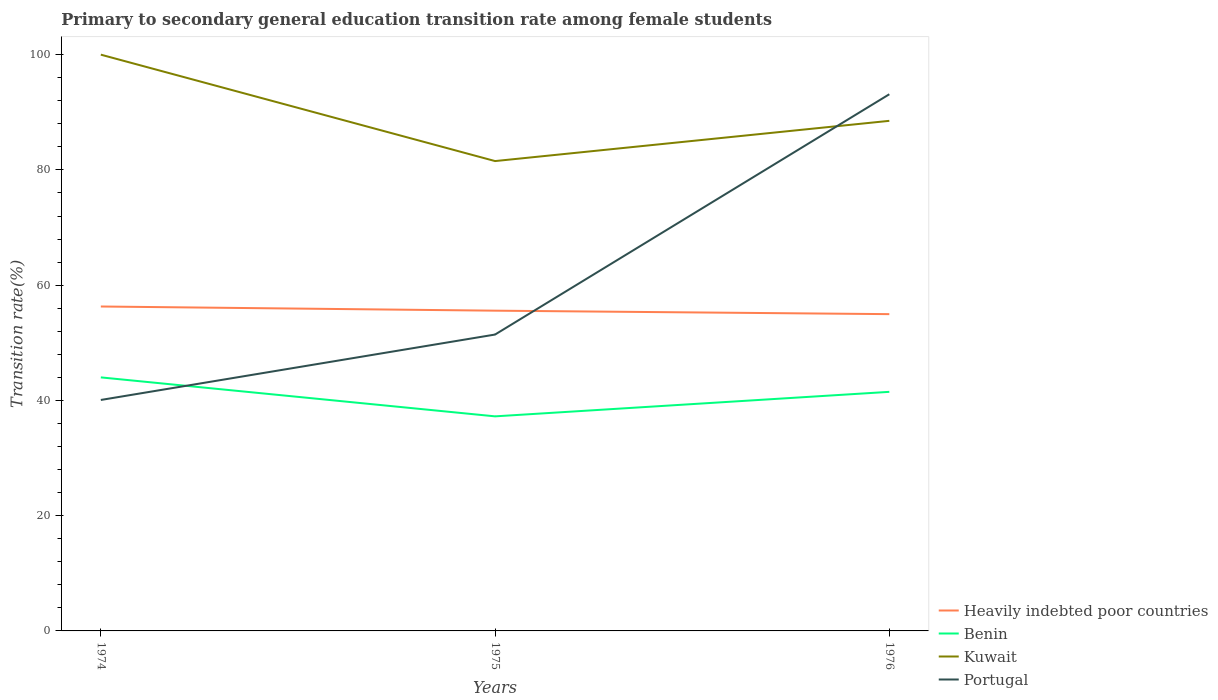Does the line corresponding to Benin intersect with the line corresponding to Kuwait?
Offer a very short reply. No. Across all years, what is the maximum transition rate in Benin?
Give a very brief answer. 37.24. In which year was the transition rate in Heavily indebted poor countries maximum?
Give a very brief answer. 1976. What is the total transition rate in Benin in the graph?
Provide a succinct answer. 6.76. What is the difference between the highest and the second highest transition rate in Portugal?
Ensure brevity in your answer.  53.05. What is the difference between the highest and the lowest transition rate in Heavily indebted poor countries?
Ensure brevity in your answer.  1. How many lines are there?
Provide a succinct answer. 4. How many years are there in the graph?
Your response must be concise. 3. Are the values on the major ticks of Y-axis written in scientific E-notation?
Your answer should be compact. No. Does the graph contain grids?
Keep it short and to the point. No. Where does the legend appear in the graph?
Make the answer very short. Bottom right. How many legend labels are there?
Your answer should be compact. 4. What is the title of the graph?
Your answer should be compact. Primary to secondary general education transition rate among female students. Does "United States" appear as one of the legend labels in the graph?
Your response must be concise. No. What is the label or title of the X-axis?
Give a very brief answer. Years. What is the label or title of the Y-axis?
Provide a short and direct response. Transition rate(%). What is the Transition rate(%) in Heavily indebted poor countries in 1974?
Your answer should be compact. 56.3. What is the Transition rate(%) of Benin in 1974?
Your response must be concise. 44. What is the Transition rate(%) in Portugal in 1974?
Your answer should be very brief. 40.08. What is the Transition rate(%) in Heavily indebted poor countries in 1975?
Offer a terse response. 55.57. What is the Transition rate(%) in Benin in 1975?
Your response must be concise. 37.24. What is the Transition rate(%) of Kuwait in 1975?
Make the answer very short. 81.53. What is the Transition rate(%) in Portugal in 1975?
Provide a succinct answer. 51.43. What is the Transition rate(%) of Heavily indebted poor countries in 1976?
Give a very brief answer. 54.97. What is the Transition rate(%) in Benin in 1976?
Keep it short and to the point. 41.49. What is the Transition rate(%) in Kuwait in 1976?
Keep it short and to the point. 88.52. What is the Transition rate(%) of Portugal in 1976?
Your response must be concise. 93.13. Across all years, what is the maximum Transition rate(%) in Heavily indebted poor countries?
Your answer should be compact. 56.3. Across all years, what is the maximum Transition rate(%) of Benin?
Your answer should be compact. 44. Across all years, what is the maximum Transition rate(%) in Portugal?
Give a very brief answer. 93.13. Across all years, what is the minimum Transition rate(%) in Heavily indebted poor countries?
Offer a terse response. 54.97. Across all years, what is the minimum Transition rate(%) of Benin?
Provide a succinct answer. 37.24. Across all years, what is the minimum Transition rate(%) in Kuwait?
Offer a terse response. 81.53. Across all years, what is the minimum Transition rate(%) of Portugal?
Your answer should be compact. 40.08. What is the total Transition rate(%) of Heavily indebted poor countries in the graph?
Offer a very short reply. 166.84. What is the total Transition rate(%) in Benin in the graph?
Provide a short and direct response. 122.72. What is the total Transition rate(%) of Kuwait in the graph?
Keep it short and to the point. 270.05. What is the total Transition rate(%) in Portugal in the graph?
Give a very brief answer. 184.64. What is the difference between the Transition rate(%) in Heavily indebted poor countries in 1974 and that in 1975?
Your answer should be compact. 0.72. What is the difference between the Transition rate(%) in Benin in 1974 and that in 1975?
Ensure brevity in your answer.  6.76. What is the difference between the Transition rate(%) in Kuwait in 1974 and that in 1975?
Offer a very short reply. 18.47. What is the difference between the Transition rate(%) of Portugal in 1974 and that in 1975?
Provide a succinct answer. -11.35. What is the difference between the Transition rate(%) of Heavily indebted poor countries in 1974 and that in 1976?
Give a very brief answer. 1.32. What is the difference between the Transition rate(%) in Benin in 1974 and that in 1976?
Give a very brief answer. 2.51. What is the difference between the Transition rate(%) of Kuwait in 1974 and that in 1976?
Your answer should be compact. 11.48. What is the difference between the Transition rate(%) of Portugal in 1974 and that in 1976?
Your response must be concise. -53.05. What is the difference between the Transition rate(%) in Heavily indebted poor countries in 1975 and that in 1976?
Provide a succinct answer. 0.6. What is the difference between the Transition rate(%) of Benin in 1975 and that in 1976?
Make the answer very short. -4.25. What is the difference between the Transition rate(%) of Kuwait in 1975 and that in 1976?
Keep it short and to the point. -6.98. What is the difference between the Transition rate(%) of Portugal in 1975 and that in 1976?
Offer a terse response. -41.7. What is the difference between the Transition rate(%) in Heavily indebted poor countries in 1974 and the Transition rate(%) in Benin in 1975?
Your answer should be compact. 19.06. What is the difference between the Transition rate(%) of Heavily indebted poor countries in 1974 and the Transition rate(%) of Kuwait in 1975?
Offer a very short reply. -25.24. What is the difference between the Transition rate(%) of Heavily indebted poor countries in 1974 and the Transition rate(%) of Portugal in 1975?
Offer a very short reply. 4.87. What is the difference between the Transition rate(%) of Benin in 1974 and the Transition rate(%) of Kuwait in 1975?
Provide a short and direct response. -37.54. What is the difference between the Transition rate(%) in Benin in 1974 and the Transition rate(%) in Portugal in 1975?
Provide a short and direct response. -7.43. What is the difference between the Transition rate(%) in Kuwait in 1974 and the Transition rate(%) in Portugal in 1975?
Your answer should be very brief. 48.57. What is the difference between the Transition rate(%) of Heavily indebted poor countries in 1974 and the Transition rate(%) of Benin in 1976?
Provide a succinct answer. 14.81. What is the difference between the Transition rate(%) of Heavily indebted poor countries in 1974 and the Transition rate(%) of Kuwait in 1976?
Give a very brief answer. -32.22. What is the difference between the Transition rate(%) of Heavily indebted poor countries in 1974 and the Transition rate(%) of Portugal in 1976?
Your answer should be compact. -36.83. What is the difference between the Transition rate(%) in Benin in 1974 and the Transition rate(%) in Kuwait in 1976?
Your answer should be very brief. -44.52. What is the difference between the Transition rate(%) of Benin in 1974 and the Transition rate(%) of Portugal in 1976?
Ensure brevity in your answer.  -49.13. What is the difference between the Transition rate(%) of Kuwait in 1974 and the Transition rate(%) of Portugal in 1976?
Make the answer very short. 6.87. What is the difference between the Transition rate(%) of Heavily indebted poor countries in 1975 and the Transition rate(%) of Benin in 1976?
Your answer should be compact. 14.09. What is the difference between the Transition rate(%) of Heavily indebted poor countries in 1975 and the Transition rate(%) of Kuwait in 1976?
Provide a succinct answer. -32.94. What is the difference between the Transition rate(%) of Heavily indebted poor countries in 1975 and the Transition rate(%) of Portugal in 1976?
Provide a short and direct response. -37.56. What is the difference between the Transition rate(%) of Benin in 1975 and the Transition rate(%) of Kuwait in 1976?
Offer a terse response. -51.28. What is the difference between the Transition rate(%) in Benin in 1975 and the Transition rate(%) in Portugal in 1976?
Give a very brief answer. -55.89. What is the difference between the Transition rate(%) in Kuwait in 1975 and the Transition rate(%) in Portugal in 1976?
Offer a very short reply. -11.6. What is the average Transition rate(%) of Heavily indebted poor countries per year?
Ensure brevity in your answer.  55.61. What is the average Transition rate(%) in Benin per year?
Your response must be concise. 40.91. What is the average Transition rate(%) in Kuwait per year?
Your response must be concise. 90.02. What is the average Transition rate(%) in Portugal per year?
Keep it short and to the point. 61.55. In the year 1974, what is the difference between the Transition rate(%) of Heavily indebted poor countries and Transition rate(%) of Benin?
Keep it short and to the point. 12.3. In the year 1974, what is the difference between the Transition rate(%) of Heavily indebted poor countries and Transition rate(%) of Kuwait?
Provide a short and direct response. -43.7. In the year 1974, what is the difference between the Transition rate(%) in Heavily indebted poor countries and Transition rate(%) in Portugal?
Your answer should be compact. 16.22. In the year 1974, what is the difference between the Transition rate(%) of Benin and Transition rate(%) of Kuwait?
Your answer should be very brief. -56. In the year 1974, what is the difference between the Transition rate(%) in Benin and Transition rate(%) in Portugal?
Your answer should be very brief. 3.92. In the year 1974, what is the difference between the Transition rate(%) of Kuwait and Transition rate(%) of Portugal?
Make the answer very short. 59.92. In the year 1975, what is the difference between the Transition rate(%) in Heavily indebted poor countries and Transition rate(%) in Benin?
Provide a succinct answer. 18.34. In the year 1975, what is the difference between the Transition rate(%) of Heavily indebted poor countries and Transition rate(%) of Kuwait?
Your response must be concise. -25.96. In the year 1975, what is the difference between the Transition rate(%) of Heavily indebted poor countries and Transition rate(%) of Portugal?
Ensure brevity in your answer.  4.14. In the year 1975, what is the difference between the Transition rate(%) of Benin and Transition rate(%) of Kuwait?
Your response must be concise. -44.3. In the year 1975, what is the difference between the Transition rate(%) in Benin and Transition rate(%) in Portugal?
Your answer should be compact. -14.2. In the year 1975, what is the difference between the Transition rate(%) in Kuwait and Transition rate(%) in Portugal?
Provide a short and direct response. 30.1. In the year 1976, what is the difference between the Transition rate(%) in Heavily indebted poor countries and Transition rate(%) in Benin?
Your answer should be very brief. 13.48. In the year 1976, what is the difference between the Transition rate(%) in Heavily indebted poor countries and Transition rate(%) in Kuwait?
Ensure brevity in your answer.  -33.54. In the year 1976, what is the difference between the Transition rate(%) of Heavily indebted poor countries and Transition rate(%) of Portugal?
Give a very brief answer. -38.16. In the year 1976, what is the difference between the Transition rate(%) in Benin and Transition rate(%) in Kuwait?
Ensure brevity in your answer.  -47.03. In the year 1976, what is the difference between the Transition rate(%) of Benin and Transition rate(%) of Portugal?
Make the answer very short. -51.64. In the year 1976, what is the difference between the Transition rate(%) of Kuwait and Transition rate(%) of Portugal?
Provide a short and direct response. -4.61. What is the ratio of the Transition rate(%) in Heavily indebted poor countries in 1974 to that in 1975?
Provide a succinct answer. 1.01. What is the ratio of the Transition rate(%) in Benin in 1974 to that in 1975?
Your answer should be very brief. 1.18. What is the ratio of the Transition rate(%) of Kuwait in 1974 to that in 1975?
Offer a terse response. 1.23. What is the ratio of the Transition rate(%) in Portugal in 1974 to that in 1975?
Provide a short and direct response. 0.78. What is the ratio of the Transition rate(%) in Heavily indebted poor countries in 1974 to that in 1976?
Make the answer very short. 1.02. What is the ratio of the Transition rate(%) in Benin in 1974 to that in 1976?
Your response must be concise. 1.06. What is the ratio of the Transition rate(%) of Kuwait in 1974 to that in 1976?
Offer a very short reply. 1.13. What is the ratio of the Transition rate(%) of Portugal in 1974 to that in 1976?
Your response must be concise. 0.43. What is the ratio of the Transition rate(%) in Heavily indebted poor countries in 1975 to that in 1976?
Make the answer very short. 1.01. What is the ratio of the Transition rate(%) in Benin in 1975 to that in 1976?
Keep it short and to the point. 0.9. What is the ratio of the Transition rate(%) in Kuwait in 1975 to that in 1976?
Make the answer very short. 0.92. What is the ratio of the Transition rate(%) of Portugal in 1975 to that in 1976?
Offer a very short reply. 0.55. What is the difference between the highest and the second highest Transition rate(%) in Heavily indebted poor countries?
Your answer should be very brief. 0.72. What is the difference between the highest and the second highest Transition rate(%) in Benin?
Offer a very short reply. 2.51. What is the difference between the highest and the second highest Transition rate(%) of Kuwait?
Your answer should be compact. 11.48. What is the difference between the highest and the second highest Transition rate(%) in Portugal?
Make the answer very short. 41.7. What is the difference between the highest and the lowest Transition rate(%) of Heavily indebted poor countries?
Your answer should be compact. 1.32. What is the difference between the highest and the lowest Transition rate(%) in Benin?
Keep it short and to the point. 6.76. What is the difference between the highest and the lowest Transition rate(%) of Kuwait?
Ensure brevity in your answer.  18.47. What is the difference between the highest and the lowest Transition rate(%) in Portugal?
Provide a succinct answer. 53.05. 